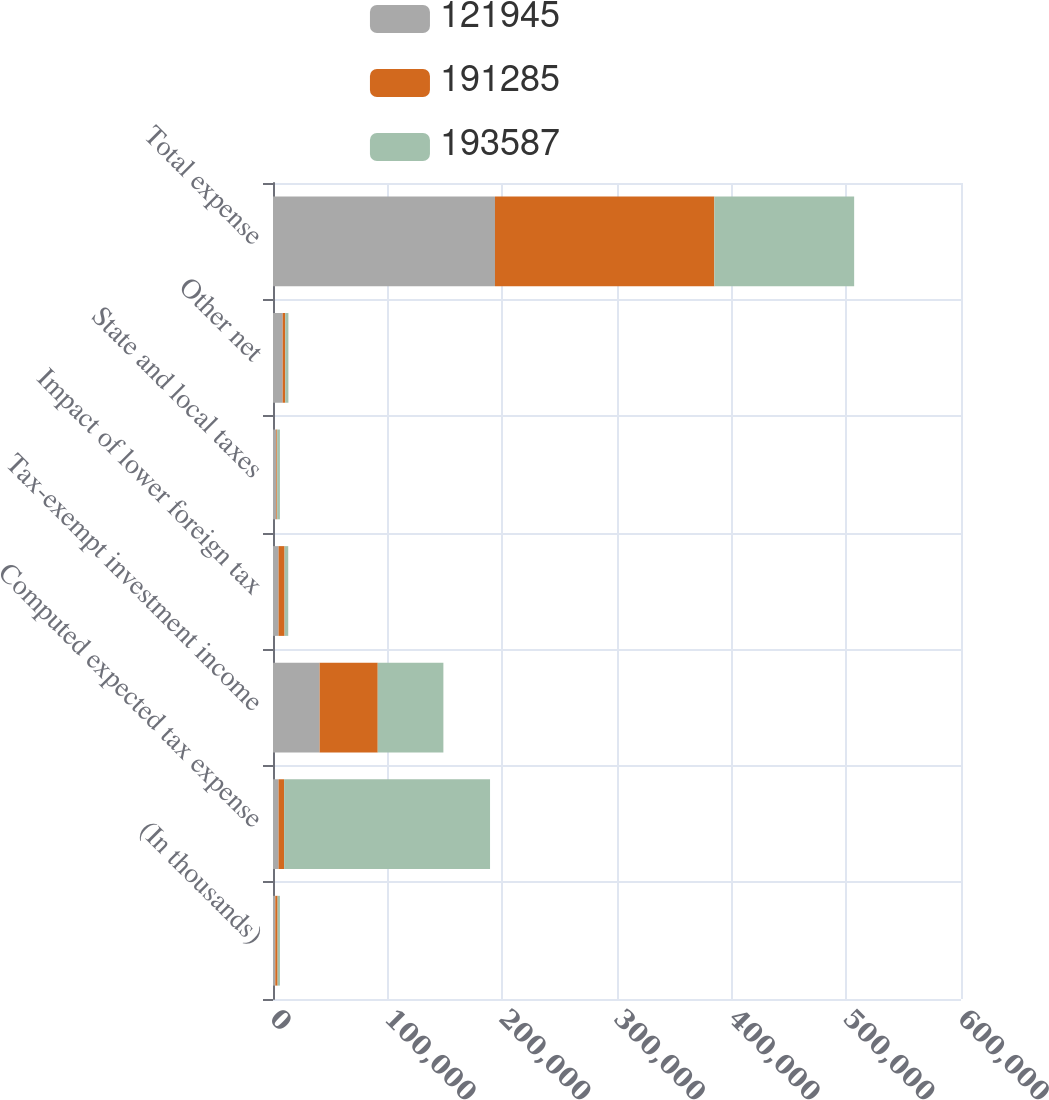Convert chart to OTSL. <chart><loc_0><loc_0><loc_500><loc_500><stacked_bar_chart><ecel><fcel>(In thousands)<fcel>Computed expected tax expense<fcel>Tax-exempt investment income<fcel>Impact of lower foreign tax<fcel>State and local taxes<fcel>Other net<fcel>Total expense<nl><fcel>121945<fcel>2013<fcel>4851<fcel>40679<fcel>4851<fcel>2906<fcel>8400<fcel>193587<nl><fcel>191285<fcel>2012<fcel>4851<fcel>50665<fcel>5234<fcel>753<fcel>2262<fcel>191285<nl><fcel>193587<fcel>2011<fcel>179580<fcel>57246<fcel>3199<fcel>2355<fcel>2783<fcel>121945<nl></chart> 